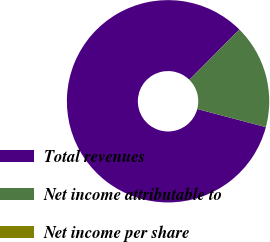<chart> <loc_0><loc_0><loc_500><loc_500><pie_chart><fcel>Total revenues<fcel>Net income attributable to<fcel>Net income per share<nl><fcel>83.33%<fcel>16.67%<fcel>0.0%<nl></chart> 